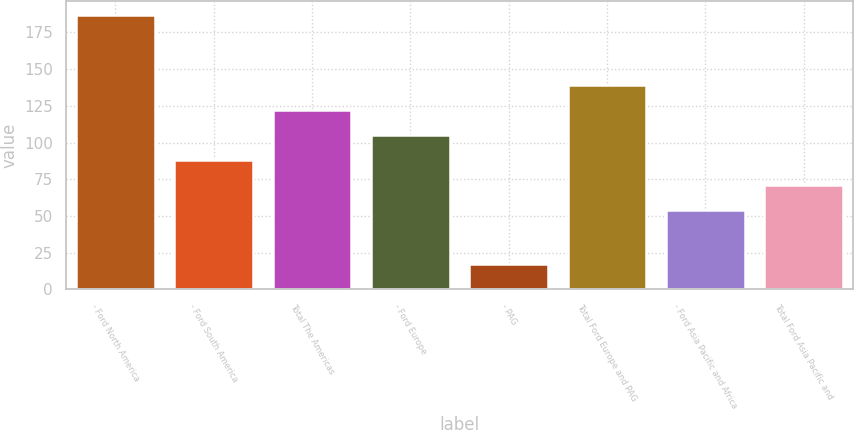Convert chart. <chart><loc_0><loc_0><loc_500><loc_500><bar_chart><fcel>- Ford North America<fcel>- Ford South America<fcel>Total The Americas<fcel>- Ford Europe<fcel>- PAG<fcel>Total Ford Europe and PAG<fcel>- Ford Asia Pacific and Africa<fcel>Total Ford Asia Pacific and<nl><fcel>187<fcel>88<fcel>122<fcel>105<fcel>17<fcel>139<fcel>54<fcel>71<nl></chart> 